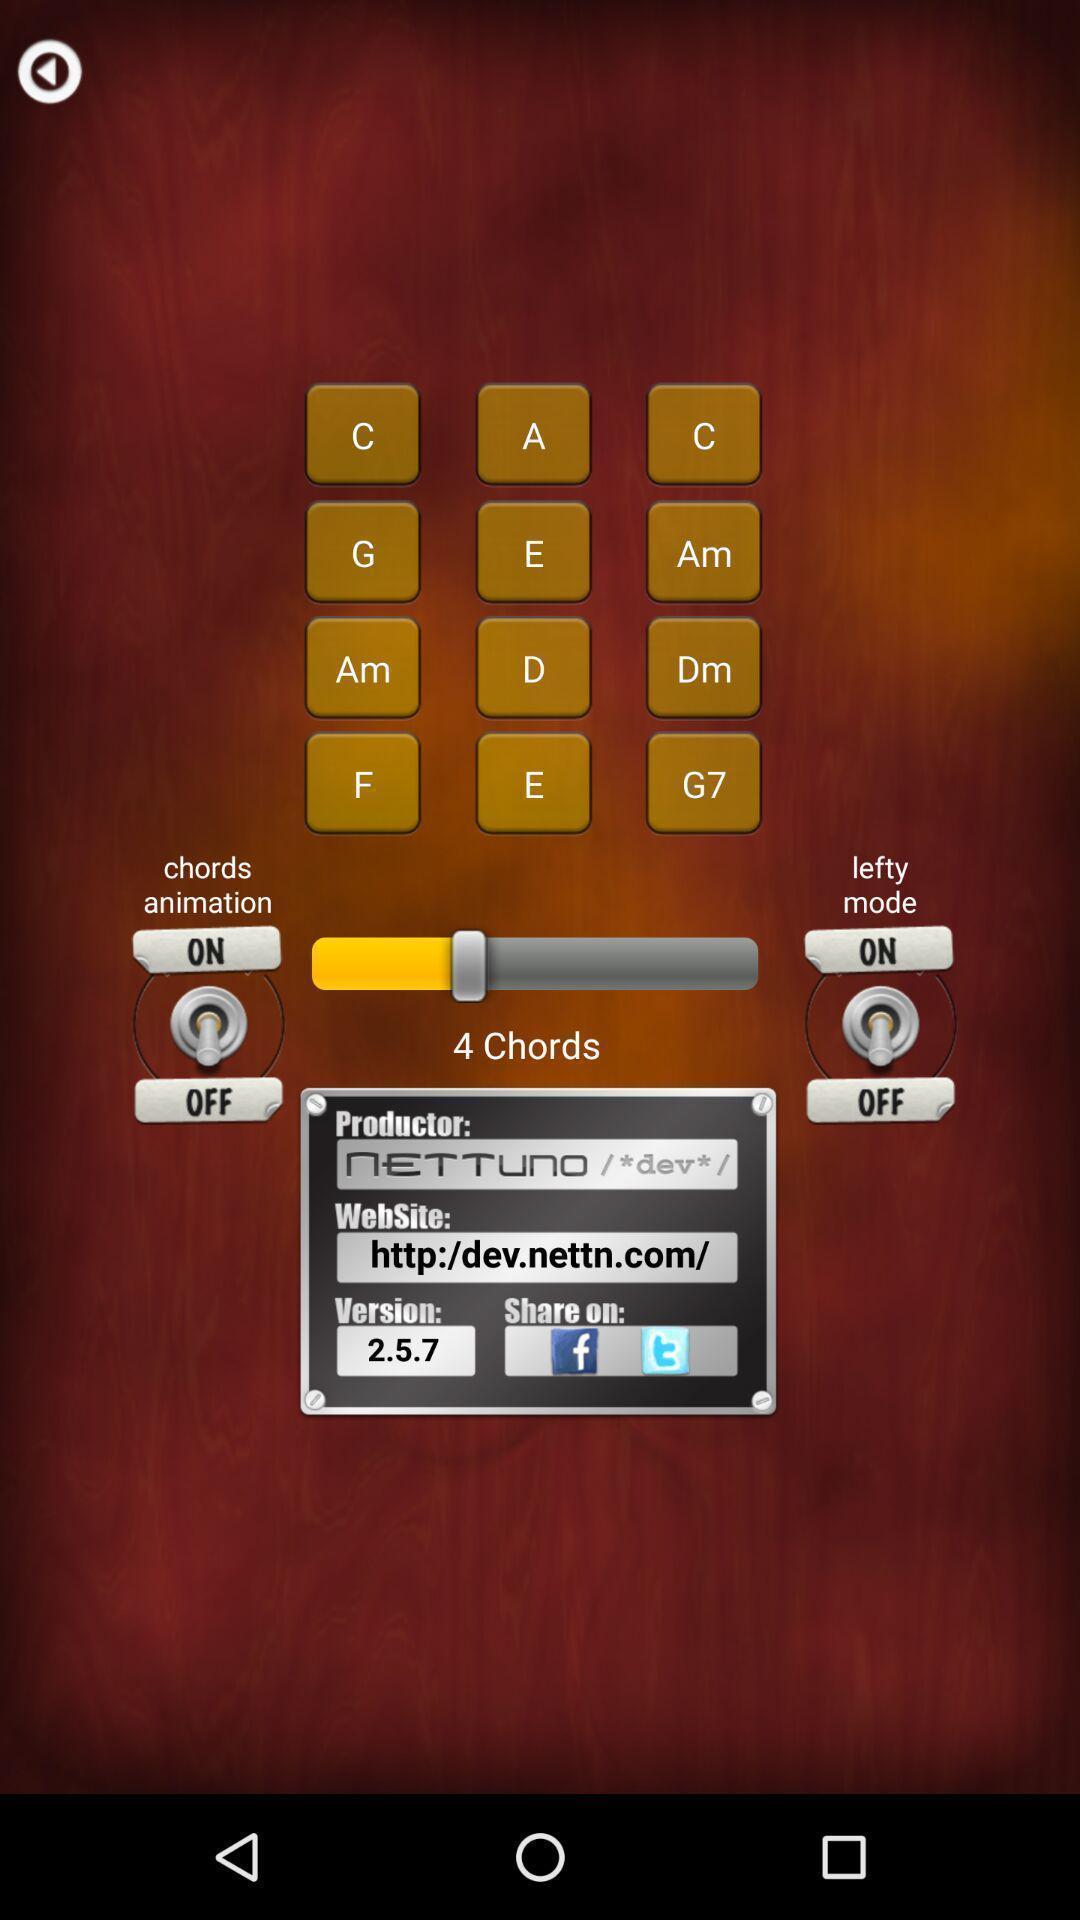Describe the key features of this screenshot. Start and stop app showing various chords. 